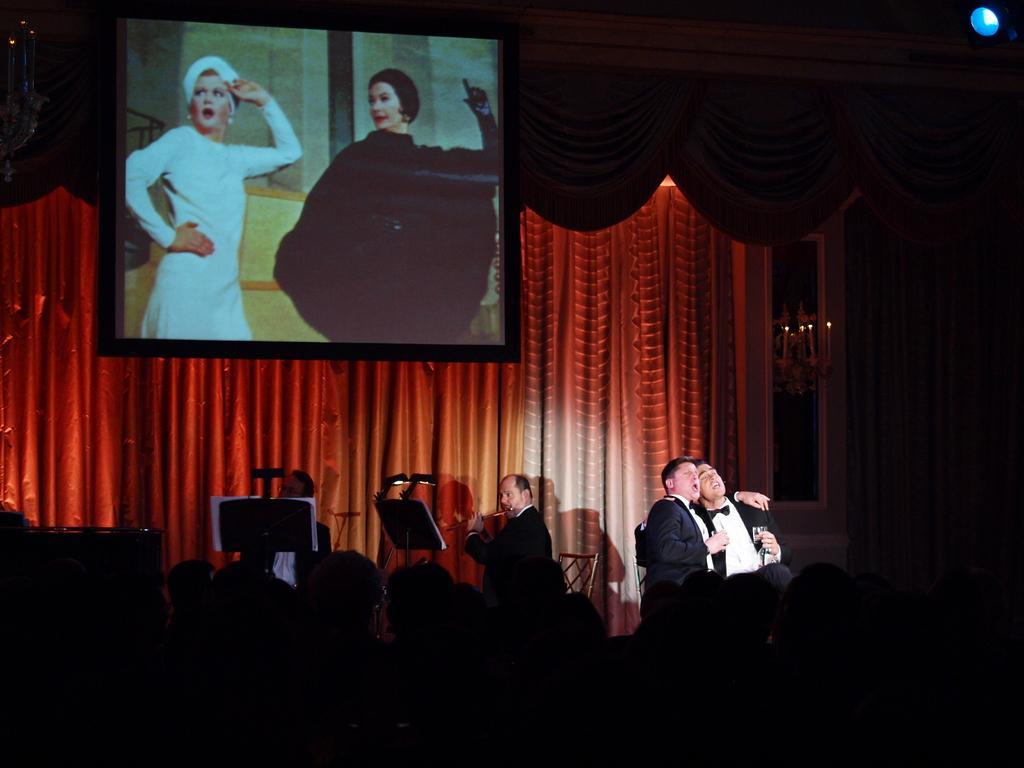How would you summarize this image in a sentence or two? In this picture I can see group of people, there are four persons sitting on the chairs, there are mikes with the mics stands, there are books on the musical book stands, there are chandeliers, there is a focus light, there is a screen, and in the background there are curtains. 